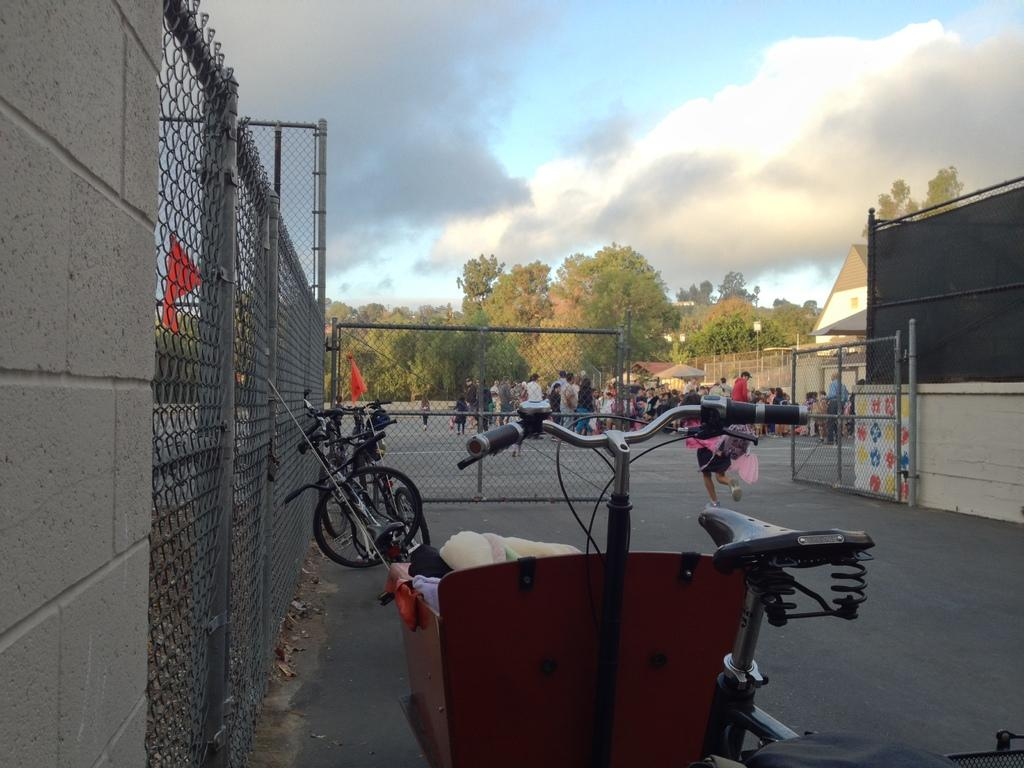What is the weather like in the image? The sky is cloudy in the image. What type of structure can be seen in the image? There is a gate in the image. What type of transportation is present in the image? There are bicycles in the image. What type of building is visible in the image? There is a house in the image. What type of storage structure is present in the image? There is a shed in the image. Who is present in the image? There are people in the image. What type of vegetation is visible in the image? There are trees in the image. What type of decorative objects are present in the image? There are flags in the image. What type of container is visible in the image? There is a basket with things in the image. What is the value of the mother in the image? There is no mother present in the image, so it is not possible to determine her value. 